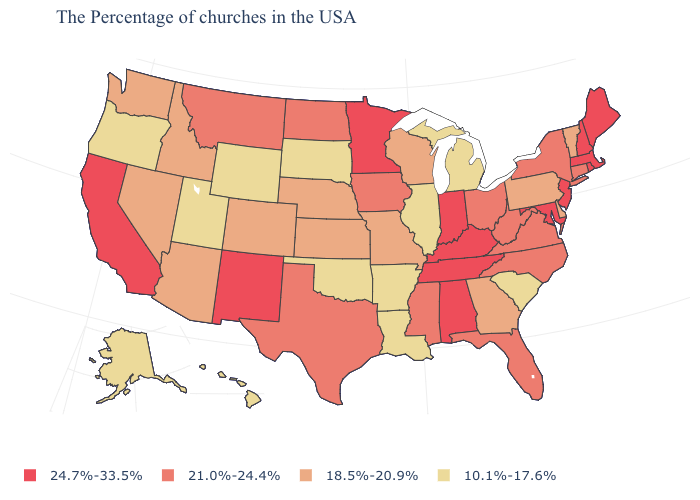Name the states that have a value in the range 18.5%-20.9%?
Keep it brief. Vermont, Delaware, Pennsylvania, Georgia, Wisconsin, Missouri, Kansas, Nebraska, Colorado, Arizona, Idaho, Nevada, Washington. What is the value of Texas?
Write a very short answer. 21.0%-24.4%. Among the states that border Colorado , does New Mexico have the highest value?
Short answer required. Yes. Name the states that have a value in the range 10.1%-17.6%?
Be succinct. South Carolina, Michigan, Illinois, Louisiana, Arkansas, Oklahoma, South Dakota, Wyoming, Utah, Oregon, Alaska, Hawaii. Does Arkansas have the highest value in the USA?
Be succinct. No. What is the highest value in the West ?
Short answer required. 24.7%-33.5%. What is the highest value in the USA?
Be succinct. 24.7%-33.5%. What is the value of Nevada?
Answer briefly. 18.5%-20.9%. Name the states that have a value in the range 10.1%-17.6%?
Give a very brief answer. South Carolina, Michigan, Illinois, Louisiana, Arkansas, Oklahoma, South Dakota, Wyoming, Utah, Oregon, Alaska, Hawaii. What is the value of Iowa?
Keep it brief. 21.0%-24.4%. What is the value of Alabama?
Write a very short answer. 24.7%-33.5%. What is the highest value in states that border North Carolina?
Write a very short answer. 24.7%-33.5%. Name the states that have a value in the range 24.7%-33.5%?
Keep it brief. Maine, Massachusetts, Rhode Island, New Hampshire, New Jersey, Maryland, Kentucky, Indiana, Alabama, Tennessee, Minnesota, New Mexico, California. What is the value of Colorado?
Give a very brief answer. 18.5%-20.9%. What is the highest value in the USA?
Answer briefly. 24.7%-33.5%. 